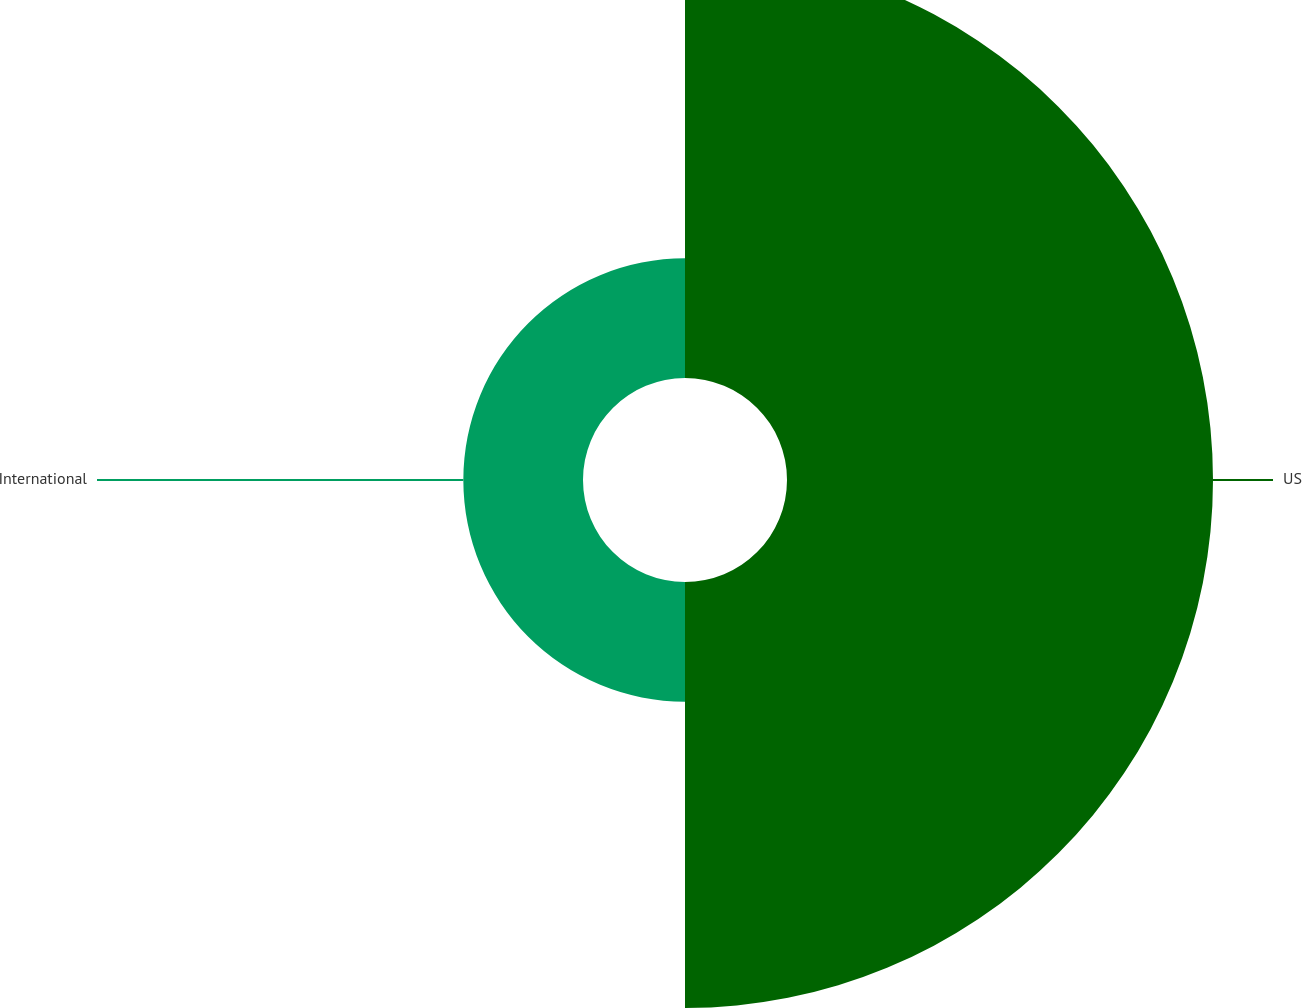<chart> <loc_0><loc_0><loc_500><loc_500><pie_chart><fcel>US<fcel>International<nl><fcel>78.07%<fcel>21.93%<nl></chart> 